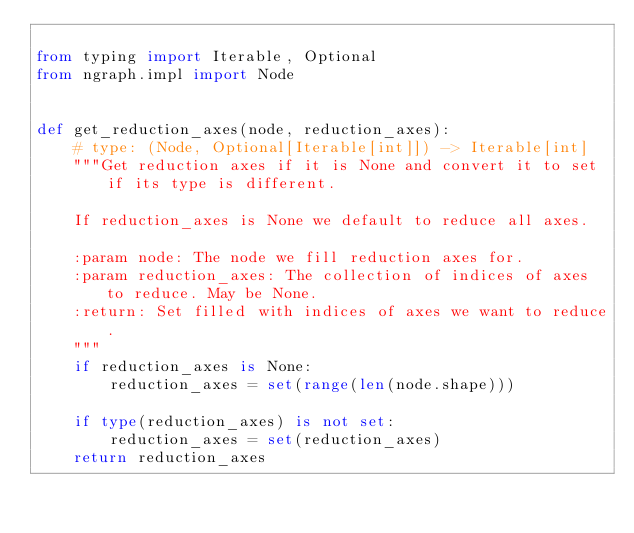<code> <loc_0><loc_0><loc_500><loc_500><_Python_>
from typing import Iterable, Optional
from ngraph.impl import Node


def get_reduction_axes(node, reduction_axes):
    # type: (Node, Optional[Iterable[int]]) -> Iterable[int]
    """Get reduction axes if it is None and convert it to set if its type is different.

    If reduction_axes is None we default to reduce all axes.

    :param node: The node we fill reduction axes for.
    :param reduction_axes: The collection of indices of axes to reduce. May be None.
    :return: Set filled with indices of axes we want to reduce.
    """
    if reduction_axes is None:
        reduction_axes = set(range(len(node.shape)))

    if type(reduction_axes) is not set:
        reduction_axes = set(reduction_axes)
    return reduction_axes
</code> 